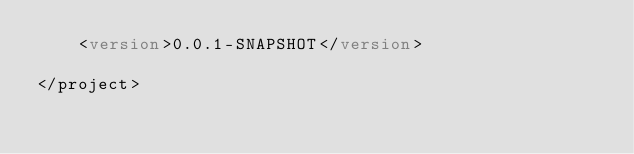<code> <loc_0><loc_0><loc_500><loc_500><_XML_>    <version>0.0.1-SNAPSHOT</version>

</project>
</code> 